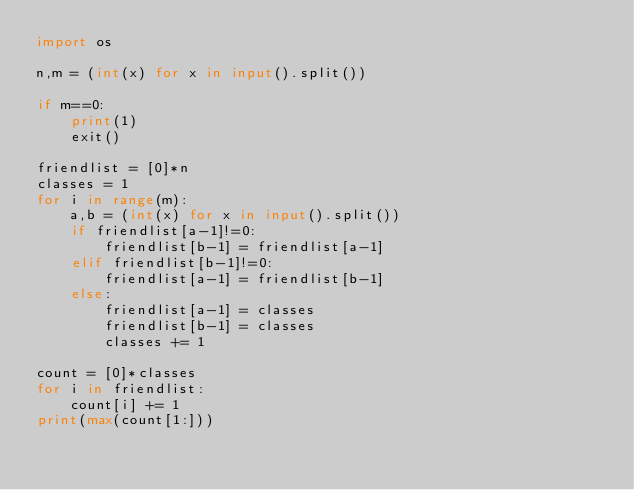Convert code to text. <code><loc_0><loc_0><loc_500><loc_500><_Python_>import os

n,m = (int(x) for x in input().split())

if m==0:
    print(1)
    exit()

friendlist = [0]*n
classes = 1
for i in range(m):
    a,b = (int(x) for x in input().split())
    if friendlist[a-1]!=0:
        friendlist[b-1] = friendlist[a-1]
    elif friendlist[b-1]!=0:
        friendlist[a-1] = friendlist[b-1]
    else:
        friendlist[a-1] = classes
        friendlist[b-1] = classes
        classes += 1

count = [0]*classes
for i in friendlist:
    count[i] += 1
print(max(count[1:]))
</code> 